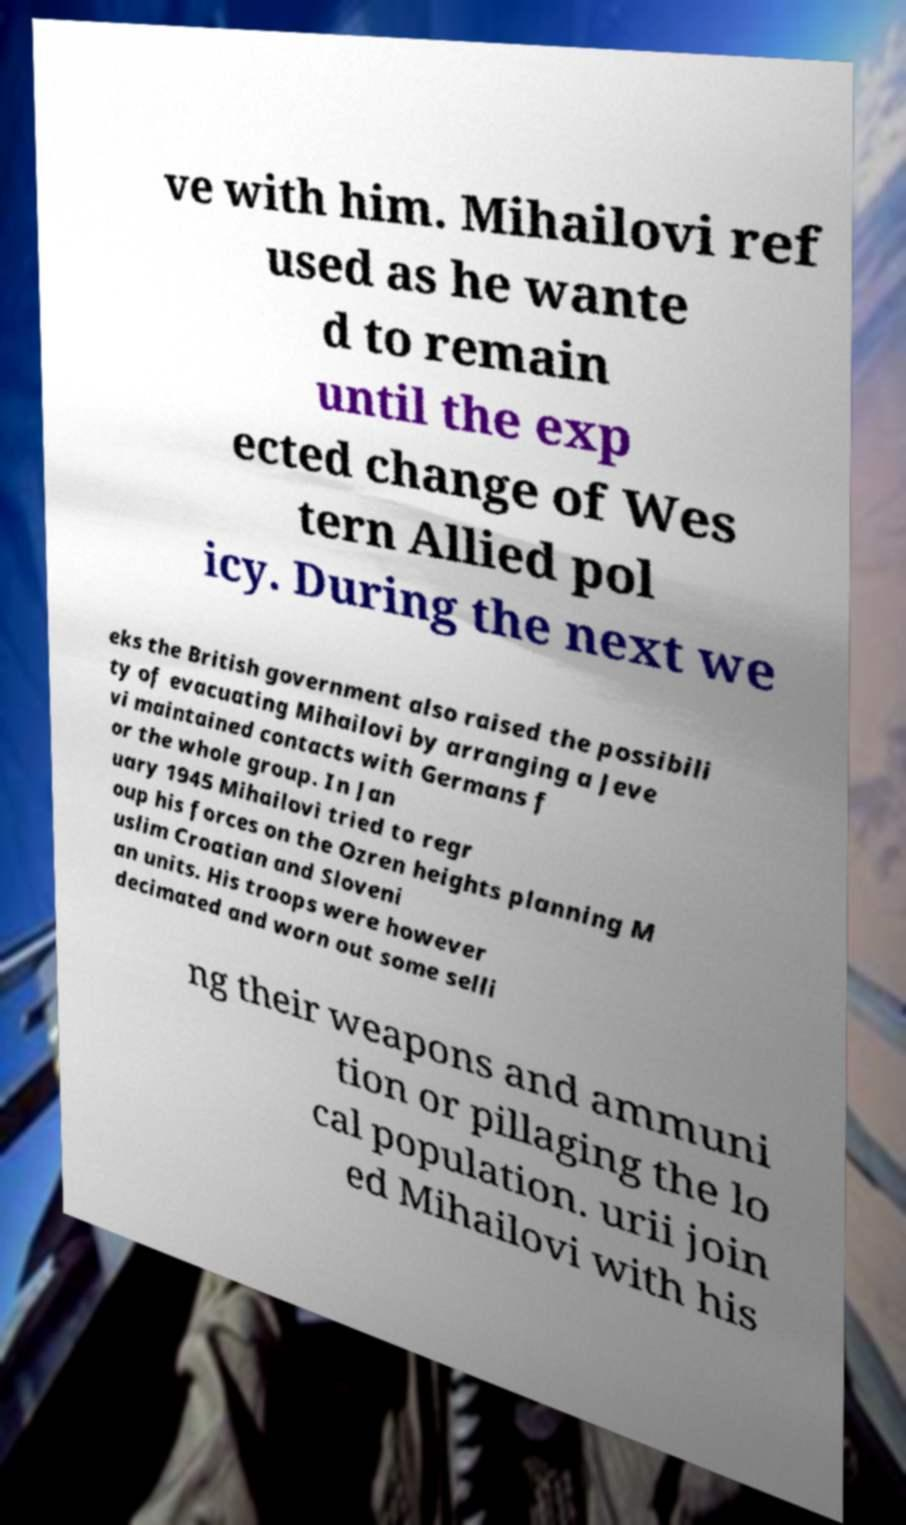For documentation purposes, I need the text within this image transcribed. Could you provide that? ve with him. Mihailovi ref used as he wante d to remain until the exp ected change of Wes tern Allied pol icy. During the next we eks the British government also raised the possibili ty of evacuating Mihailovi by arranging a Jeve vi maintained contacts with Germans f or the whole group. In Jan uary 1945 Mihailovi tried to regr oup his forces on the Ozren heights planning M uslim Croatian and Sloveni an units. His troops were however decimated and worn out some selli ng their weapons and ammuni tion or pillaging the lo cal population. urii join ed Mihailovi with his 